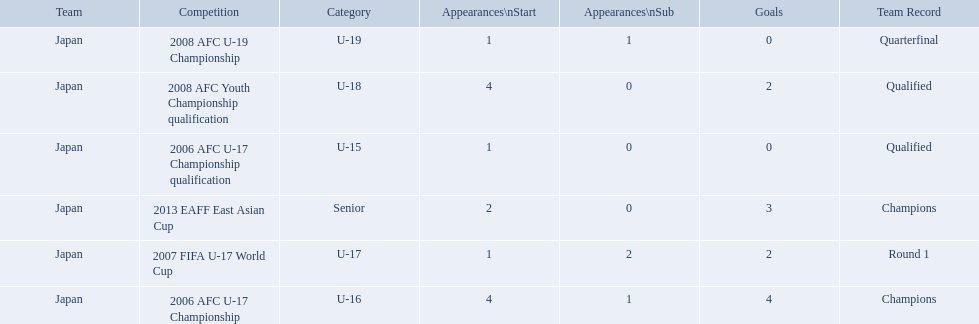What was the team record in 2006? Round 1. What competition did this belong too? 2006 AFC U-17 Championship. 